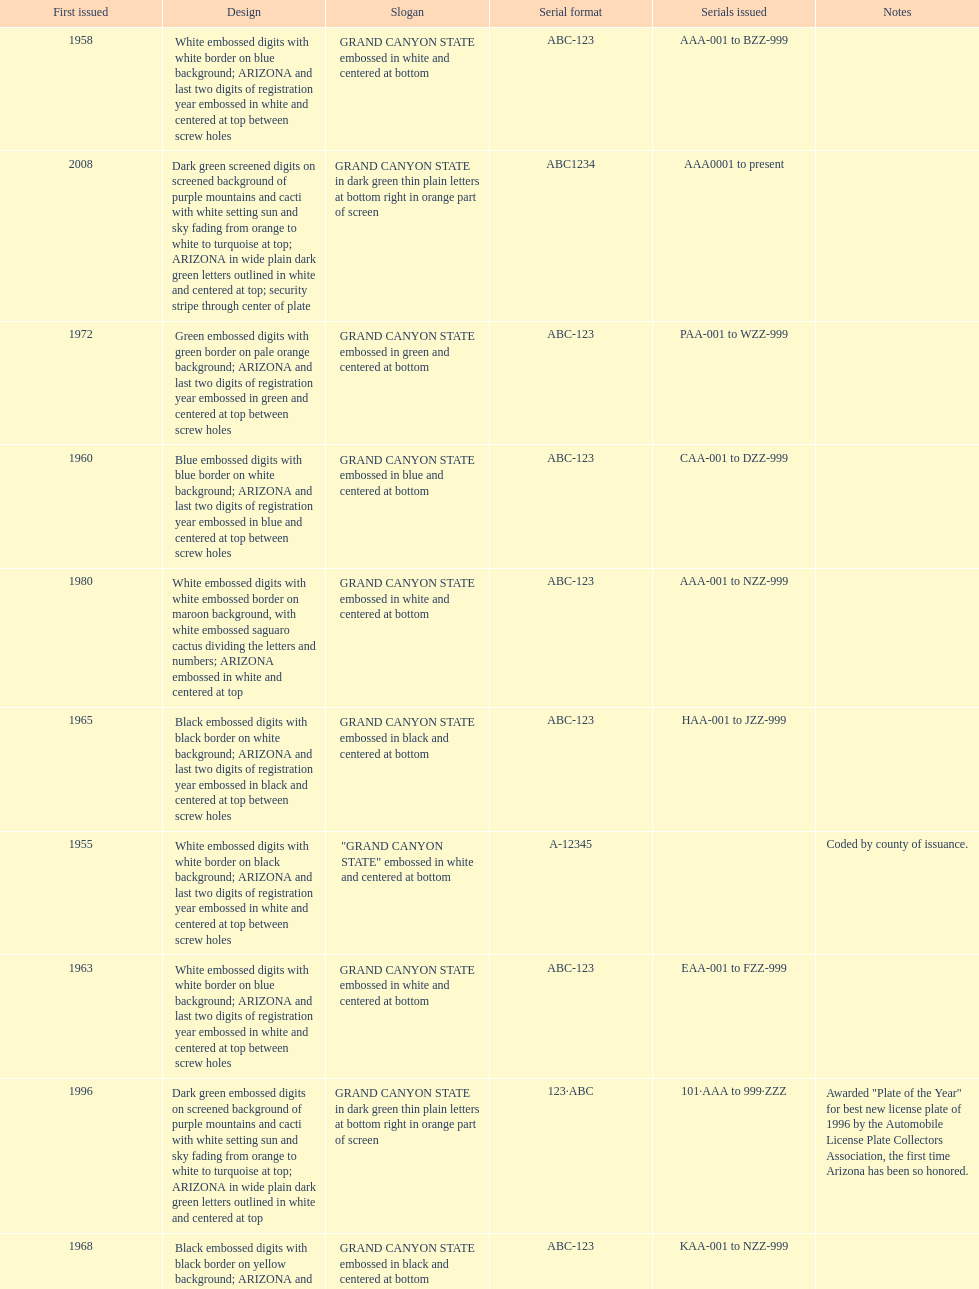What was year was the first arizona license plate made? 1955. 